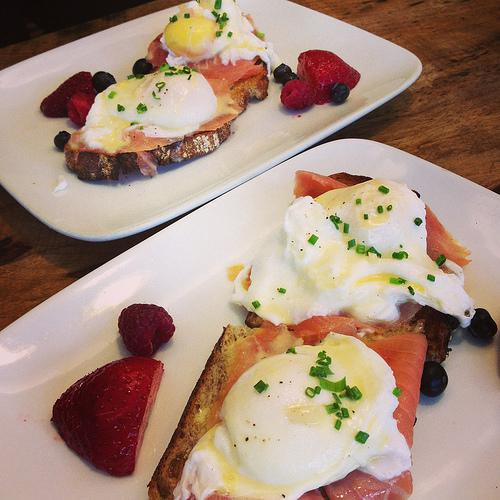Question: who took the photo?
Choices:
A. A photographer.
B. A lady.
C. A man.
D. A professional.
Answer with the letter. Answer: A Question: what color is the table?
Choices:
A. White.
B. Green.
C. Red.
D. Brown.
Answer with the letter. Answer: D Question: what is the table made of?
Choices:
A. Metal.
B. Plastic.
C. Wood.
D. Cardboard.
Answer with the letter. Answer: C Question: what is red?
Choices:
A. The fruit.
B. The apple.
C. The banana.
D. The orange.
Answer with the letter. Answer: A Question: where is the photo taken?
Choices:
A. Near the food.
B. At table.
C. Restaurant.
D. Ocean.
Answer with the letter. Answer: A 